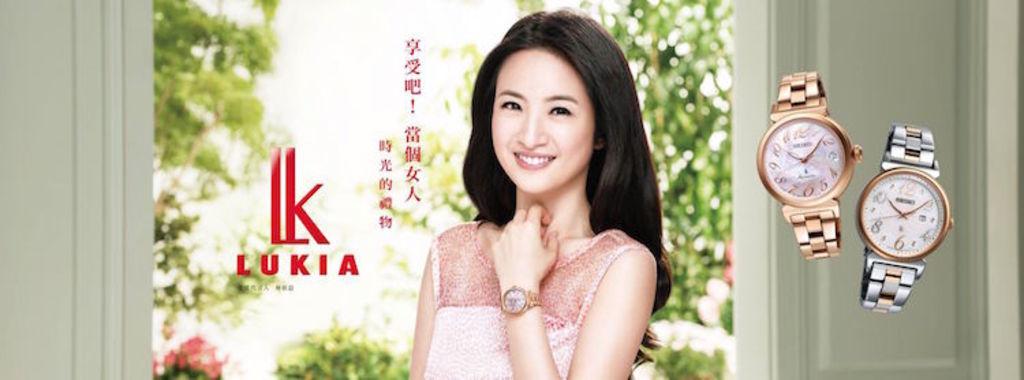What brand is the watch?
Offer a very short reply. Lukia. What is the time of the watch on the right?
Offer a terse response. 10:10. 